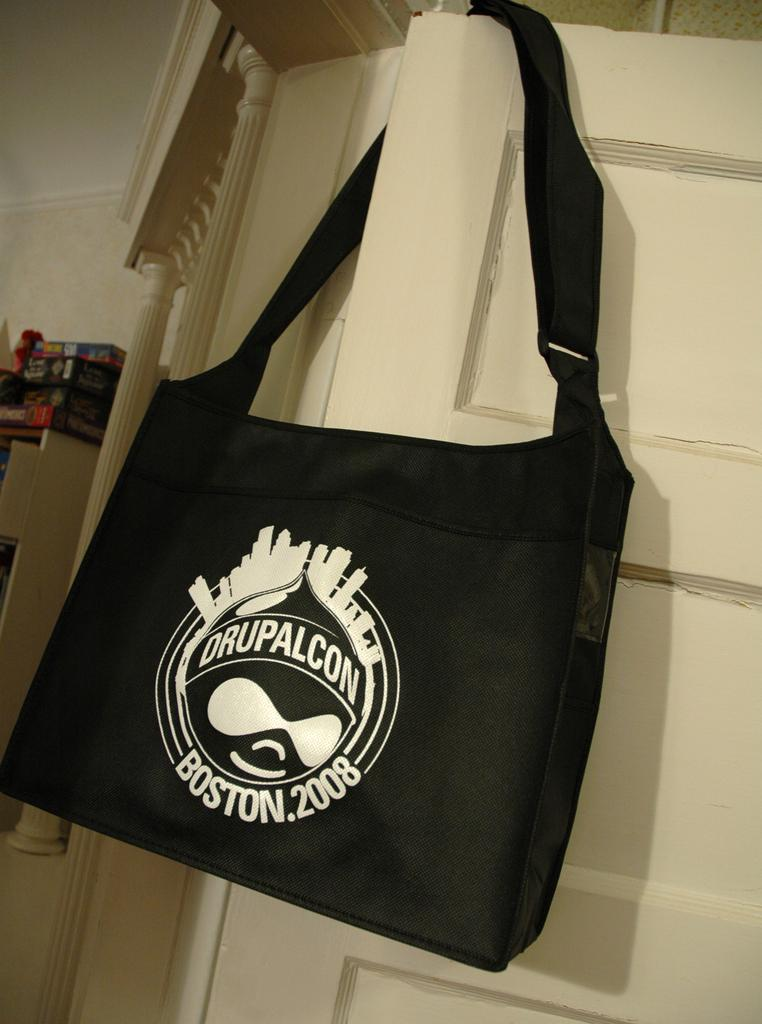What object is present in the image that can be used for carrying items? There is a bag in the image that can be used for carrying items. Where is the bag located in the image? The bag is kept on a door in the image. What can be seen on the bag? There is a logo printed on the bag. What is visible behind the door in the image? There is a wall behind the door in the image. What else can be seen on the left side of the image? There are boxes on the left side of the image. What advertisement can be seen on the wall behind the door in the image? There is no advertisement visible on the wall behind the door in the image. How many mice are hiding behind the boxes on the left side of the image? There are no mice present in the image; it only shows a bag, a door, a wall, and some boxes. 